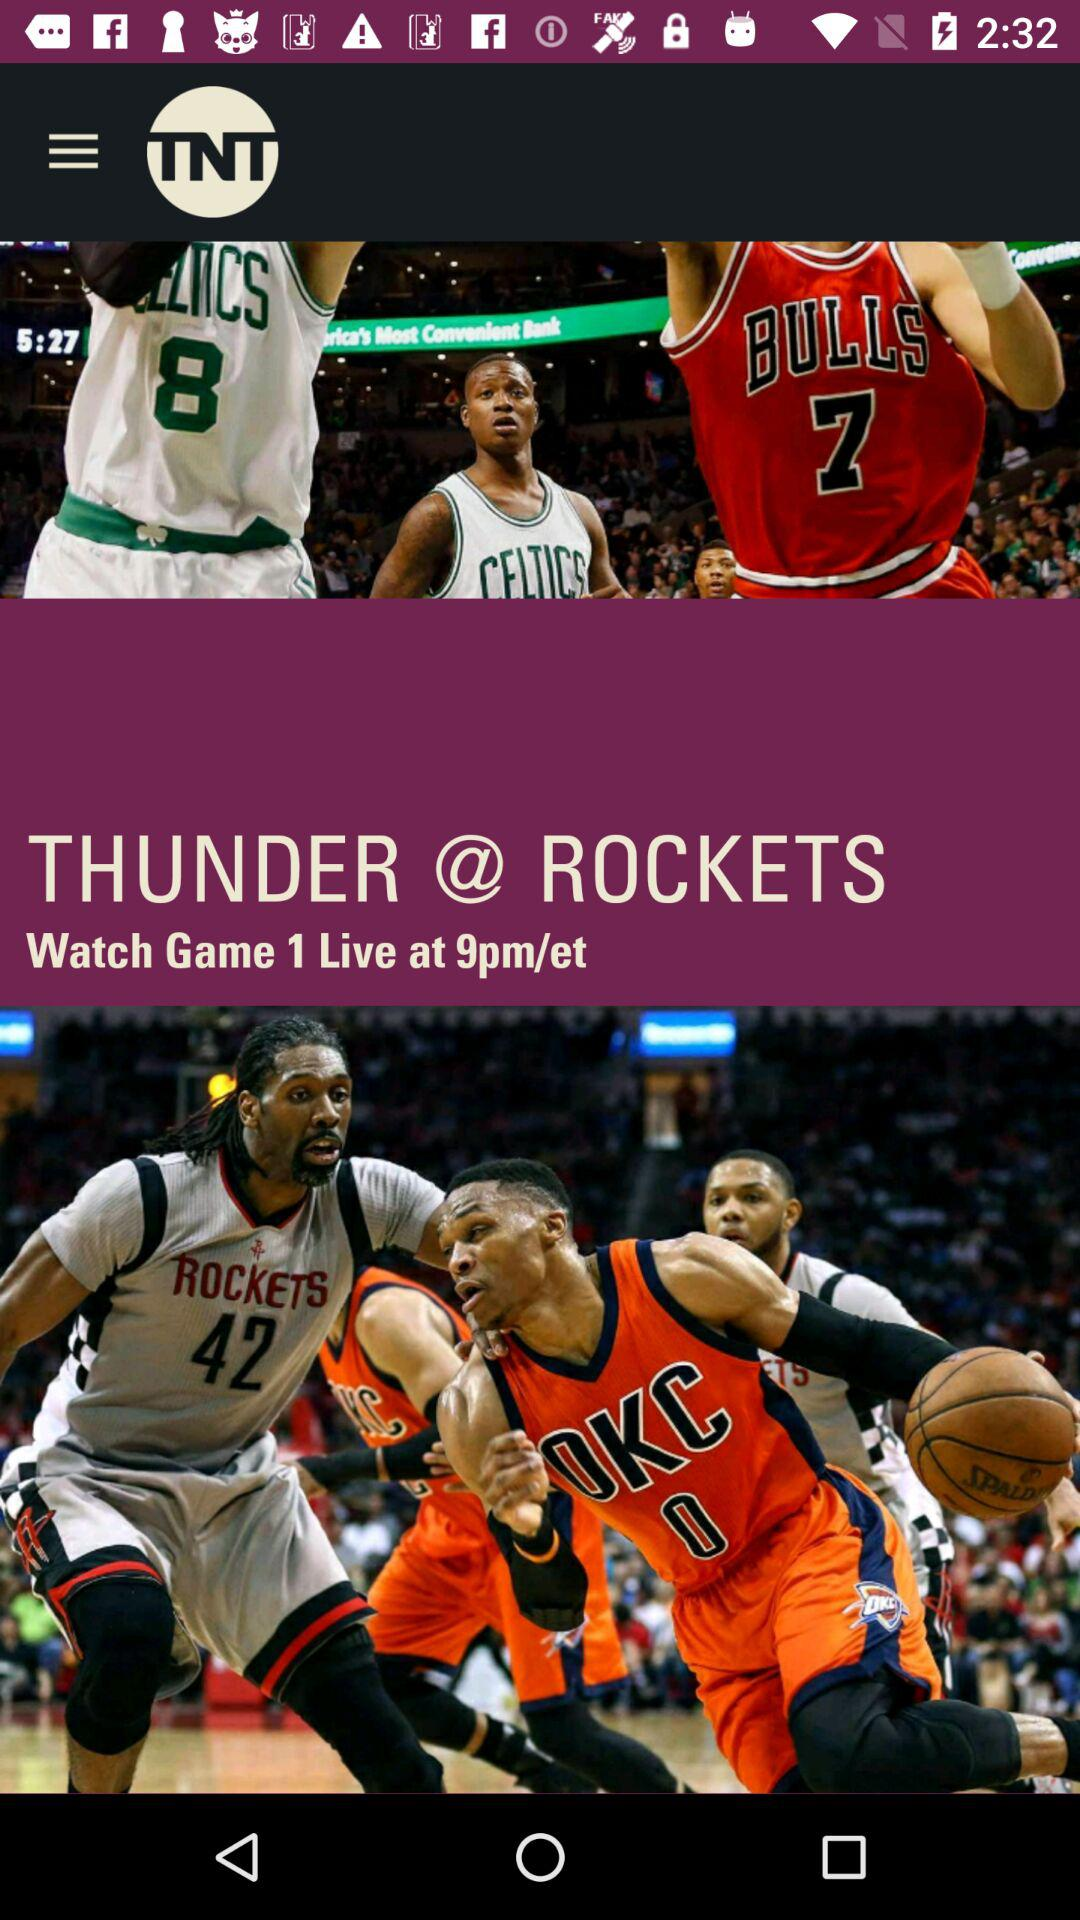What is the app's name? The app's name is "TNT". 